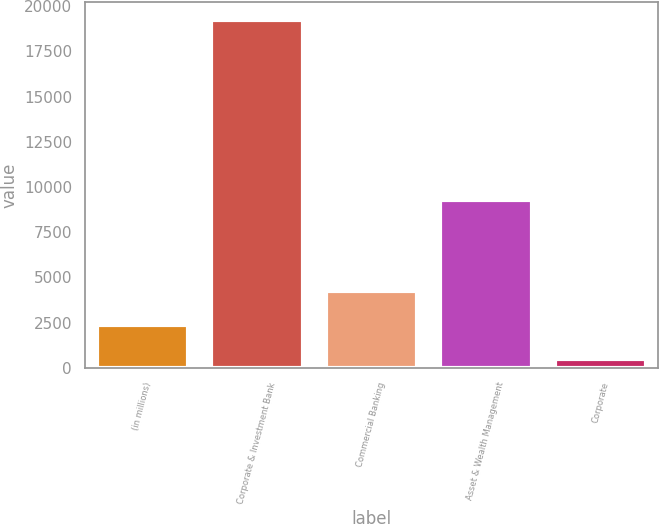<chart> <loc_0><loc_0><loc_500><loc_500><bar_chart><fcel>(in millions)<fcel>Corporate & Investment Bank<fcel>Commercial Banking<fcel>Asset & Wealth Management<fcel>Corporate<nl><fcel>2375.2<fcel>19243<fcel>4249.4<fcel>9301<fcel>501<nl></chart> 